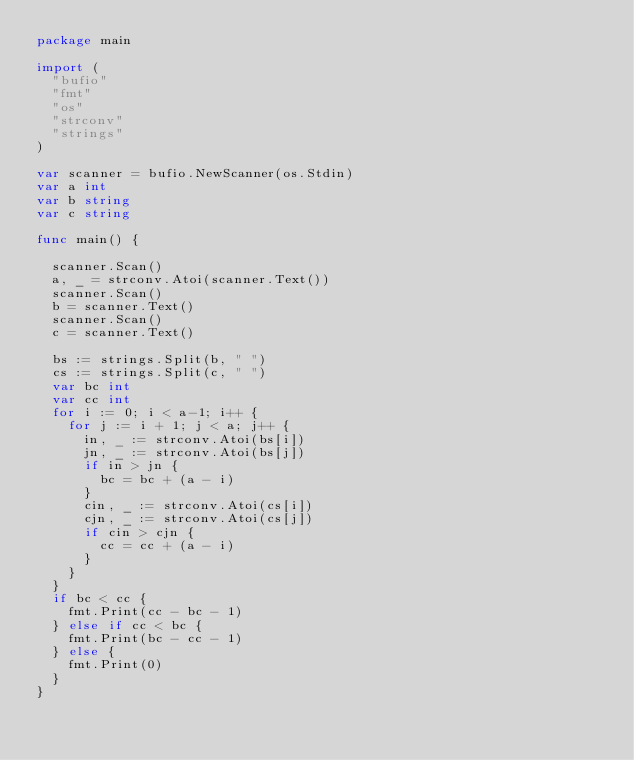<code> <loc_0><loc_0><loc_500><loc_500><_Go_>package main

import (
	"bufio"
	"fmt"
	"os"
	"strconv"
	"strings"
)

var scanner = bufio.NewScanner(os.Stdin)
var a int
var b string
var c string

func main() {

	scanner.Scan()
	a, _ = strconv.Atoi(scanner.Text())
	scanner.Scan()
	b = scanner.Text()
	scanner.Scan()
	c = scanner.Text()

	bs := strings.Split(b, " ")
	cs := strings.Split(c, " ")
	var bc int
	var cc int
	for i := 0; i < a-1; i++ {
		for j := i + 1; j < a; j++ {
			in, _ := strconv.Atoi(bs[i])
			jn, _ := strconv.Atoi(bs[j])
			if in > jn {
				bc = bc + (a - i)
			}
			cin, _ := strconv.Atoi(cs[i])
			cjn, _ := strconv.Atoi(cs[j])
			if cin > cjn {
				cc = cc + (a - i)
			}
		}
	}
	if bc < cc {
		fmt.Print(cc - bc - 1)
	} else if cc < bc {
		fmt.Print(bc - cc - 1)
	} else {
		fmt.Print(0)
	}
}
</code> 